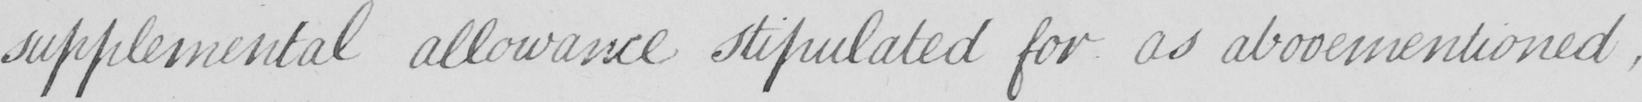What is written in this line of handwriting? supplemental allowance stipulated for as abovementioned  , 